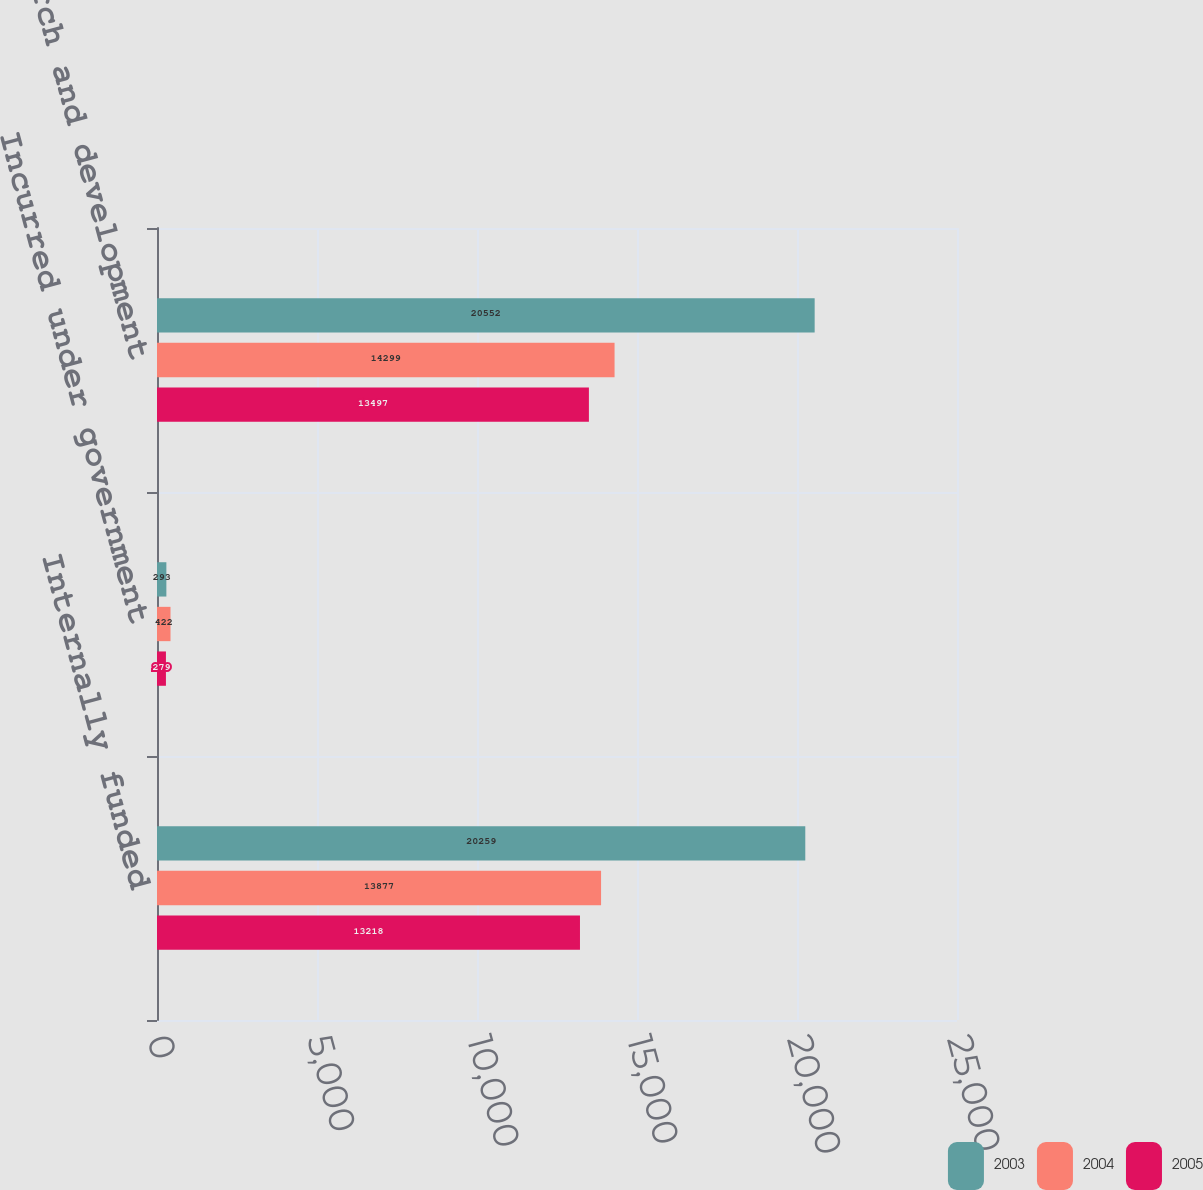Convert chart. <chart><loc_0><loc_0><loc_500><loc_500><stacked_bar_chart><ecel><fcel>Internally funded<fcel>Incurred under government<fcel>Total research and development<nl><fcel>2003<fcel>20259<fcel>293<fcel>20552<nl><fcel>2004<fcel>13877<fcel>422<fcel>14299<nl><fcel>2005<fcel>13218<fcel>279<fcel>13497<nl></chart> 